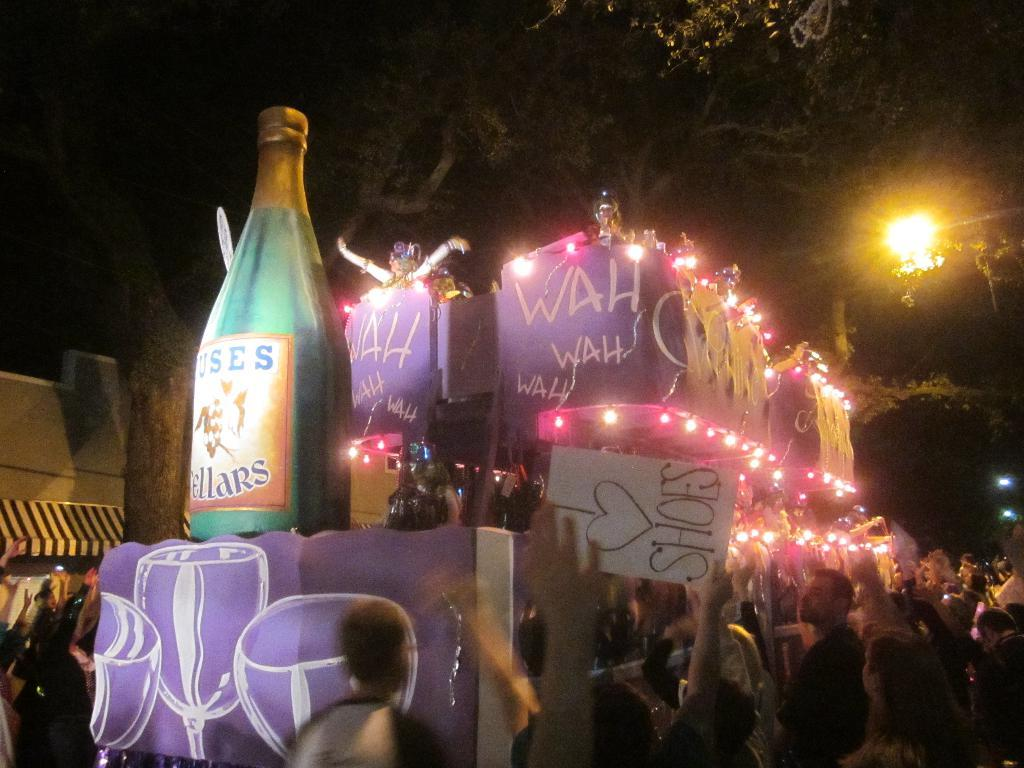<image>
Write a terse but informative summary of the picture. A crowd of people are celebrating an event and a big banner is shown with WAH WAH. 